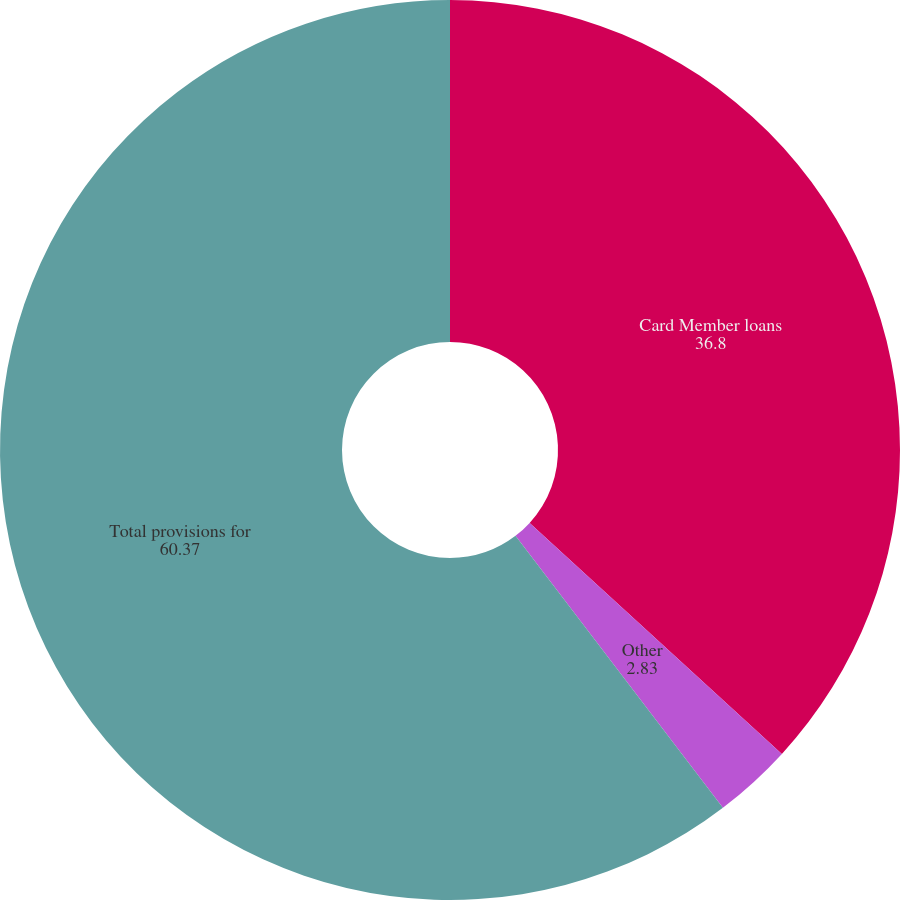<chart> <loc_0><loc_0><loc_500><loc_500><pie_chart><fcel>Card Member loans<fcel>Other<fcel>Total provisions for<nl><fcel>36.8%<fcel>2.83%<fcel>60.37%<nl></chart> 